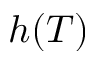Convert formula to latex. <formula><loc_0><loc_0><loc_500><loc_500>h ( T )</formula> 